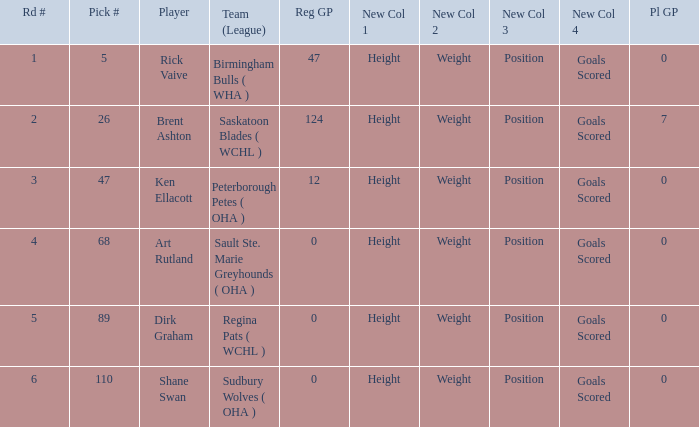How many reg GP for rick vaive in round 1? None. 